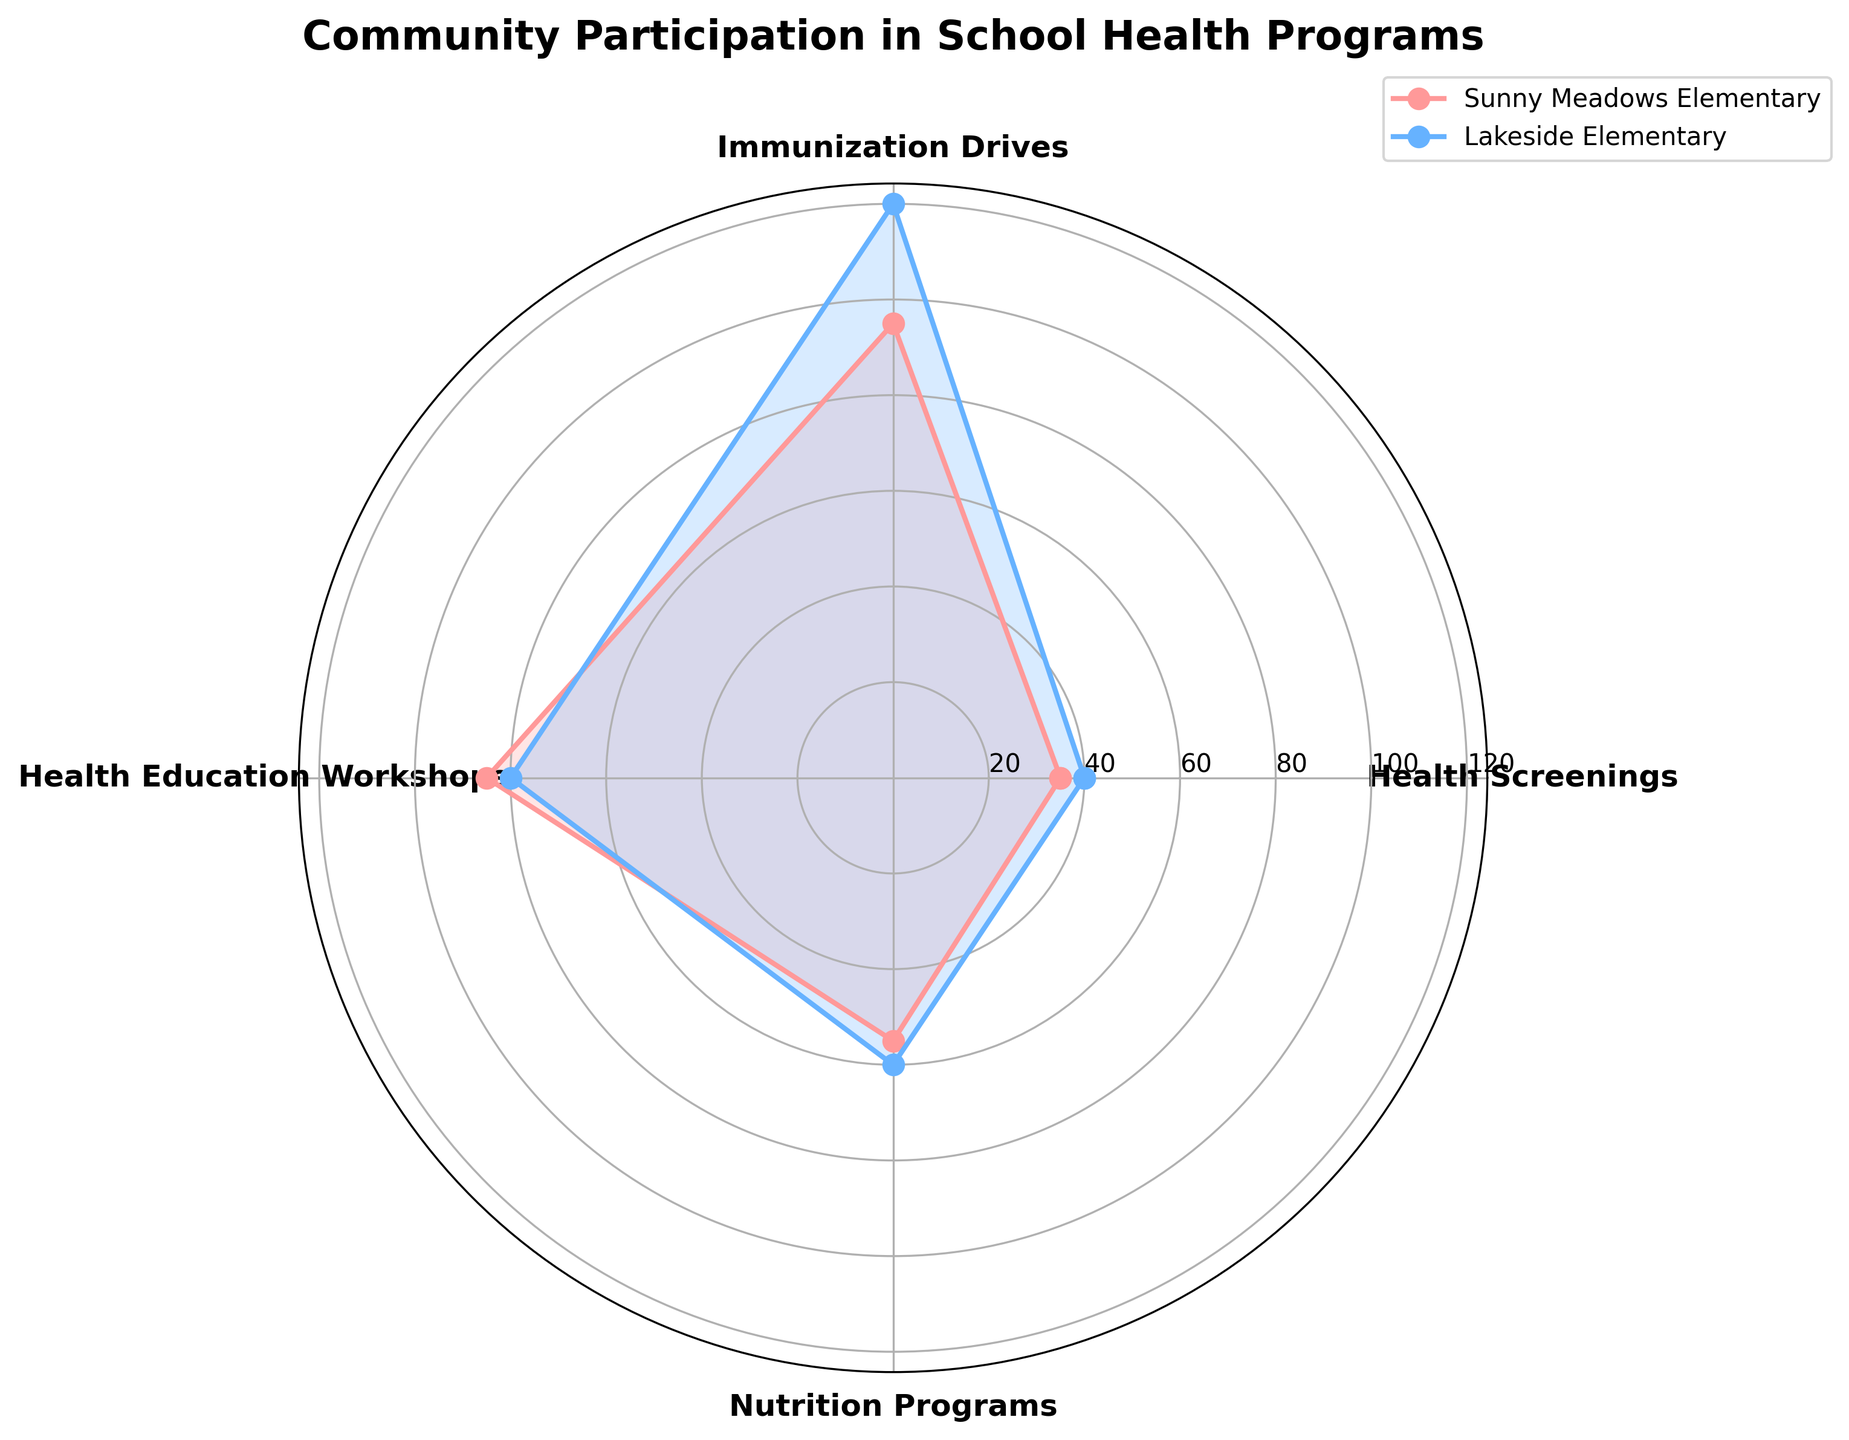what is the title of the figure? The title is the main heading text located at the top center of the figure. It helps viewers understand the subject of the plot.
Answer: Community Participation in School Health Programs How many schools participated in each health program? You can count the number of data lines corresponding to each rotary segment. There are two schools shown in the legend.
Answer: 2 Which school had more participants in Health Screenings? To compare, you look at the lengths of the segments marked 'Health Screenings' for both schools, Sunny Meadows Elementary and Lakeside Elementary. The segment for Sunny Meadows is longer.
Answer: Sunny Meadows Elementary What is the combined number of participants for Immunization Drives from both schools? Sum the number of participants for Immunization Drives from Sunny Meadows (80) and Lakeside (85). 80 + 85 = 165.
Answer: 165 Which school had the least participants in Health Education Workshops? Compare the lengths of the segments marked 'Health Education Workshops' for both schools. Lakeside Elementary has a shorter segment.
Answer: Lakeside Elementary What's the difference in participants between the school with the highest and lowest in Nutrition Programs? Find the number in the Nutrition Programs category for both schools, Sunny Meadows (60) and Lakeside (55). Then subtract the lower from the higher. 60 - 55 = 5.
Answer: 5 What is the average number of participants for Health Screenings across both schools? Sum the number of participants for Health Screenings from Sunny Meadows (120) and Lakeside (95), then divide by 2. (120 + 95) / 2 = 107.5
Answer: 107.5 Which school had more participants overall? Sum up all the numbers of participants for each school in all categories. Sunny Meadows: 120 + 80 + 40 + 60 = 300. Lakeside: 95 + 85 + 35 + 55 = 270. Compare the totals.
Answer: Sunny Meadows Elementary In which category did Lakeside Elementary have the closest number of participants compared to Sunny Meadows Elementary? Calculate and compare the differences in each category. Health Screenings: 120 vs. 95 (25 difference), Immunization Drives: 80 vs. 85 (5 difference), Health Education Workshops: 40 vs. 35 (5 difference), Nutrition Programs: 60 vs. 55 (5 difference).
Answer: Immunization Drives, Health Education Workshops, and Nutrition Programs (tie) What category had the highest number of participants at Sunny Meadows Elementary? Look at the segments representing Sunny Meadows for each category; the longest is for Health Screenings.
Answer: Health Screenings 